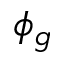<formula> <loc_0><loc_0><loc_500><loc_500>\phi _ { g }</formula> 